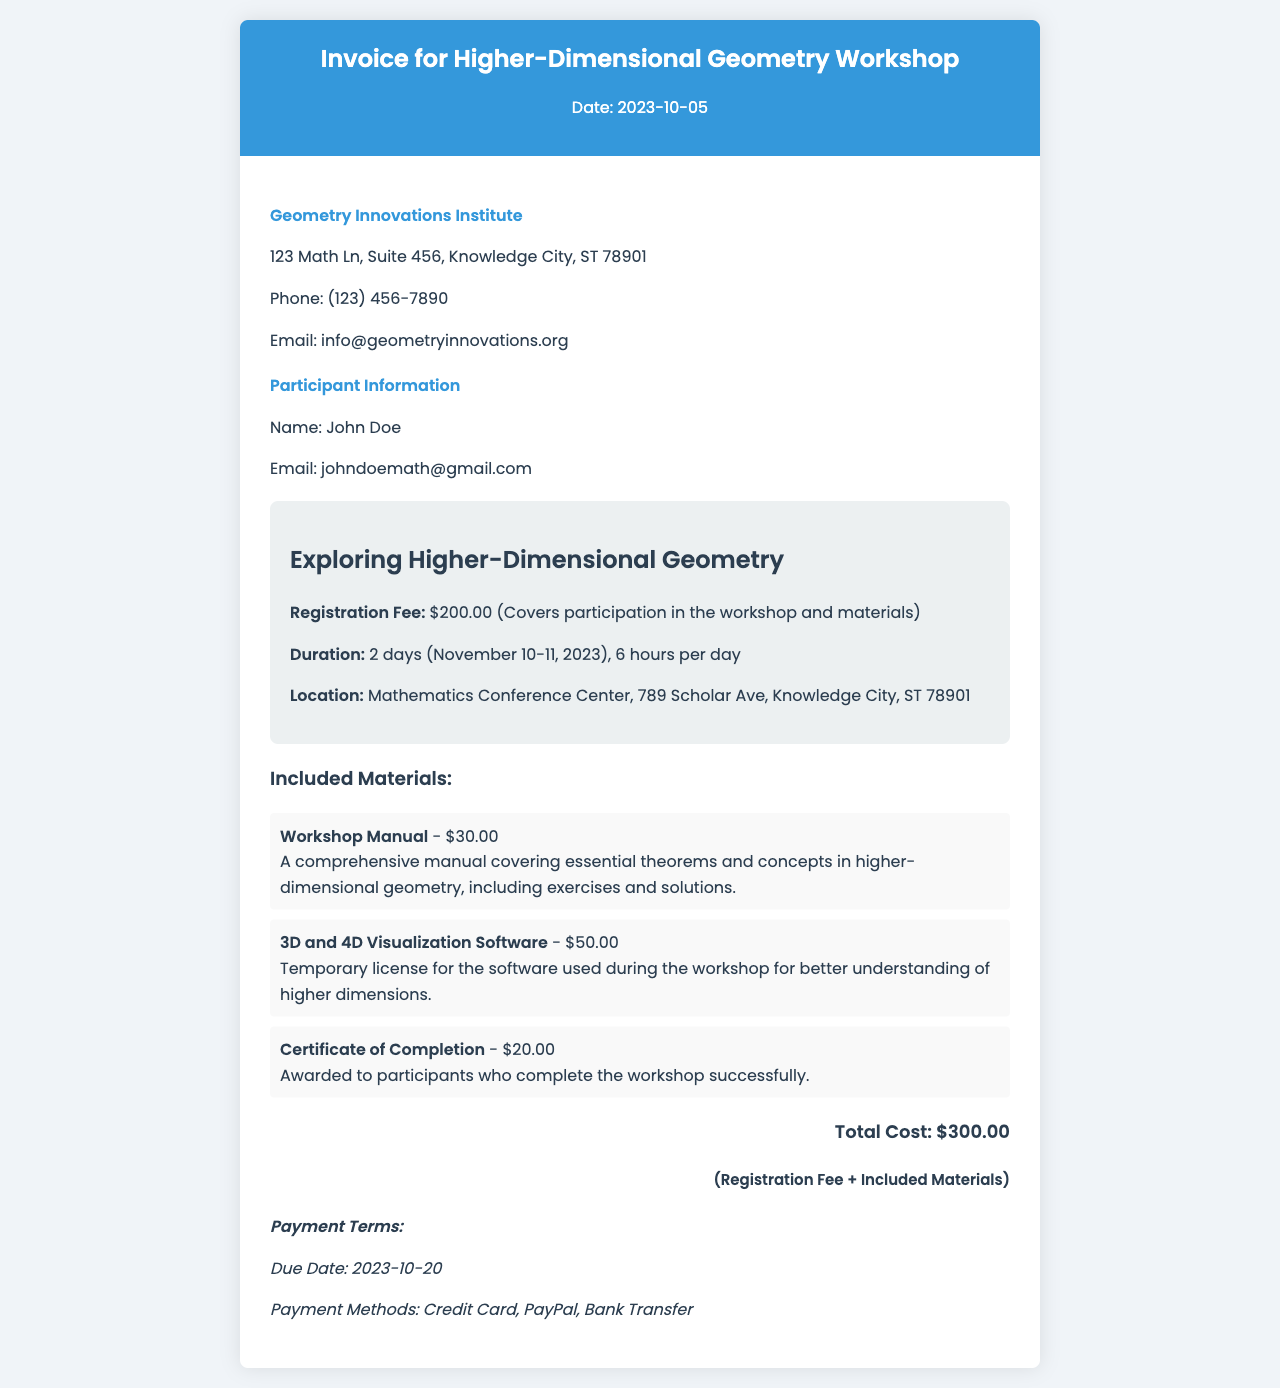What is the registration fee? The registration fee is explicitly stated in the document as covering participation in the workshop and materials.
Answer: $200.00 What are the dates of the workshop? The document specifies the duration of the workshop on November 10-11, 2023.
Answer: November 10-11, 2023 How many hours is the workshop? The document mentions the duration of the workshop in terms of hours per day.
Answer: 6 hours per day What is the total cost? The total cost is provided as the sum of the registration fee and included materials in the document.
Answer: $300.00 What is included in the workshop manual? The document describes the content of the workshop manual, including essential theorems, concepts, exercises, and solutions.
Answer: Comprehensive manual What method of payment is accepted? The document lists multiple payment methods that participants can use.
Answer: Credit Card, PayPal, Bank Transfer How many days does the workshop last? The duration of the workshop is specified clearly in the document.
Answer: 2 days What is the due date for payment? The document explicitly states the payment due date, which is when the payment should be processed.
Answer: 2023-10-20 What type of software license is included? The document details the type of software license provided to participants in the workshop materials.
Answer: Temporary license 